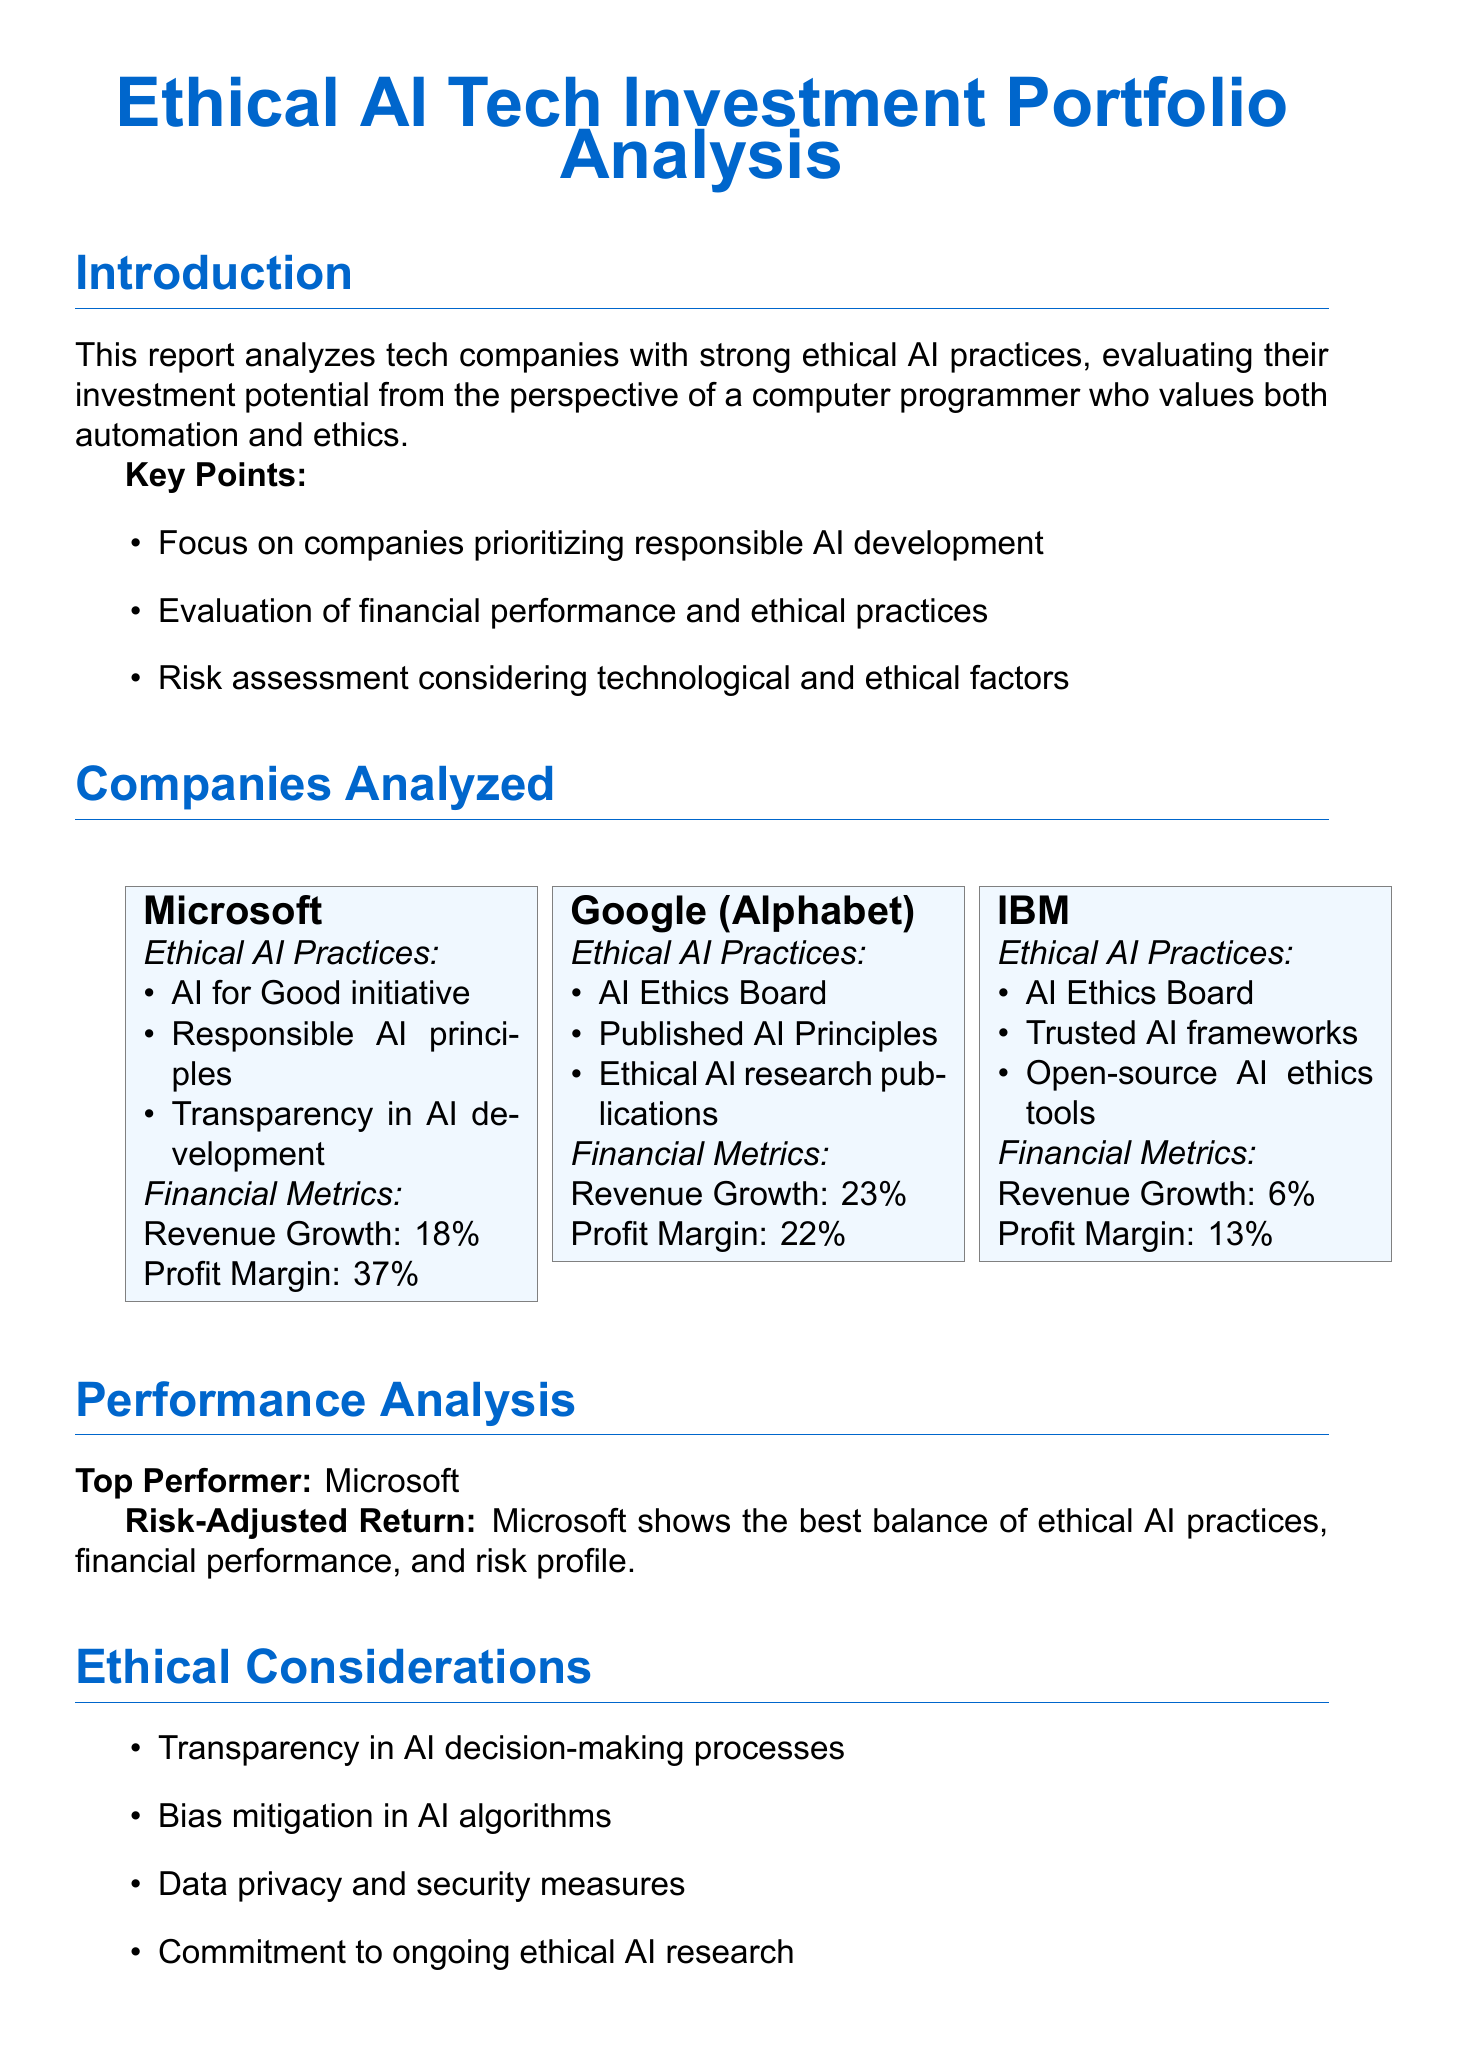What are the main focuses of the report? The key points listed in the report clarify the main focuses, including responsible AI development and ethical practices.
Answer: Companies prioritizing responsible AI development Who is the top performer according to the performance analysis? The performance analysis section specifically identifies the top performer among the analyzed companies.
Answer: Microsoft What is Google's revenue growth percentage? The financial metrics for Google revealed its revenue growth percentage.
Answer: 23% What ethical AI practice is associated with IBM? The report lists several ethical AI practices for IBM as part of its analysis.
Answer: Trusted AI frameworks What is the recommended allocation strategy in the conclusion? The conclusion section emphasizes a specific investment strategy regarding the recommended portfolio.
Answer: Larger allocation to Microsoft What is the profit margin of Microsoft? The report provides Microsoft's profit margin as part of its financial metrics.
Answer: 37% What risks are associated with IBM according to the risk assessment? The document provides the risk assessment for IBM and characterizes its level.
Answer: Medium to High 